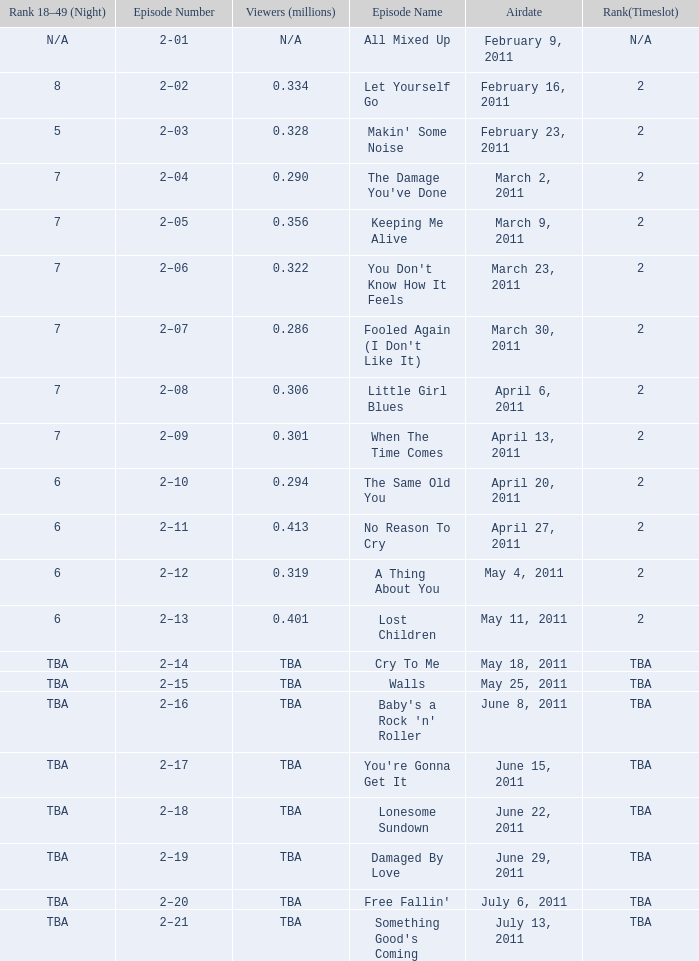What is the total rank on airdate march 30, 2011? 1.0. 